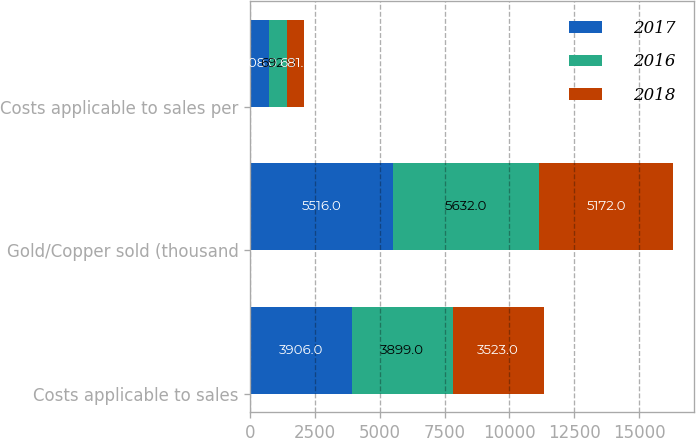<chart> <loc_0><loc_0><loc_500><loc_500><stacked_bar_chart><ecel><fcel>Costs applicable to sales<fcel>Gold/Copper sold (thousand<fcel>Costs applicable to sales per<nl><fcel>2017<fcel>3906<fcel>5516<fcel>708<nl><fcel>2016<fcel>3899<fcel>5632<fcel>692<nl><fcel>2018<fcel>3523<fcel>5172<fcel>681<nl></chart> 